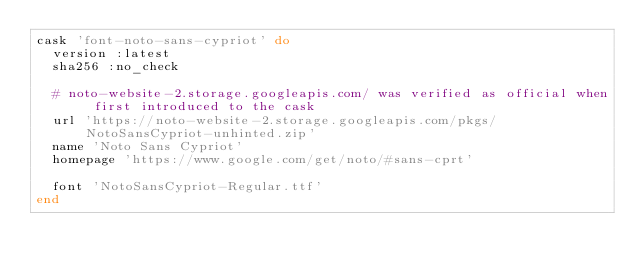Convert code to text. <code><loc_0><loc_0><loc_500><loc_500><_Ruby_>cask 'font-noto-sans-cypriot' do
  version :latest
  sha256 :no_check

  # noto-website-2.storage.googleapis.com/ was verified as official when first introduced to the cask
  url 'https://noto-website-2.storage.googleapis.com/pkgs/NotoSansCypriot-unhinted.zip'
  name 'Noto Sans Cypriot'
  homepage 'https://www.google.com/get/noto/#sans-cprt'

  font 'NotoSansCypriot-Regular.ttf'
end
</code> 